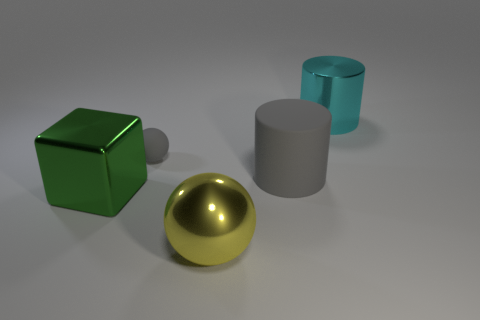Add 4 purple rubber spheres. How many objects exist? 9 Subtract all cylinders. How many objects are left? 3 Subtract 1 cyan cylinders. How many objects are left? 4 Subtract all big gray objects. Subtract all tiny gray rubber objects. How many objects are left? 3 Add 4 big yellow metal spheres. How many big yellow metal spheres are left? 5 Add 4 large blue metal cylinders. How many large blue metal cylinders exist? 4 